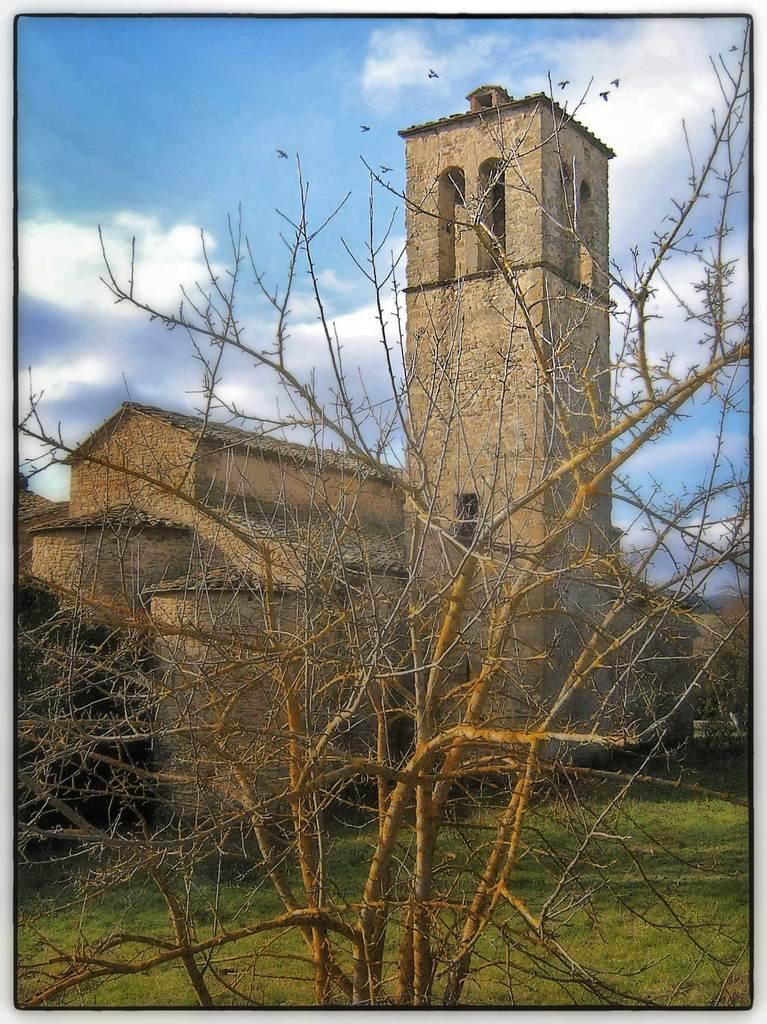Can you describe this image briefly? In the image there is a fort and around the fort there is grass, there is a dry plant in the foreground. 